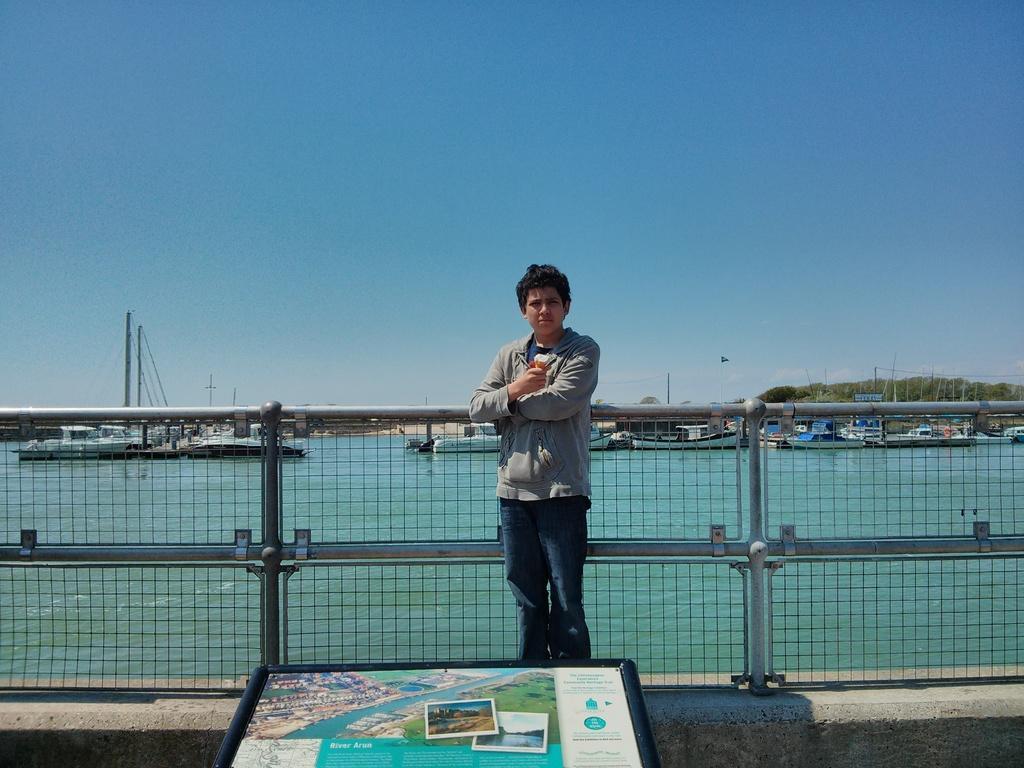Could you give a brief overview of what you see in this image? At the bottom of this image, there is a boat having images and texts. In the background, there is a person in a gray color shirt, standing on the wall. Behind this person, there is a fence. Outside this fence, there are boats on the water. In the background, there are mountains and there are clouds in the sky. 